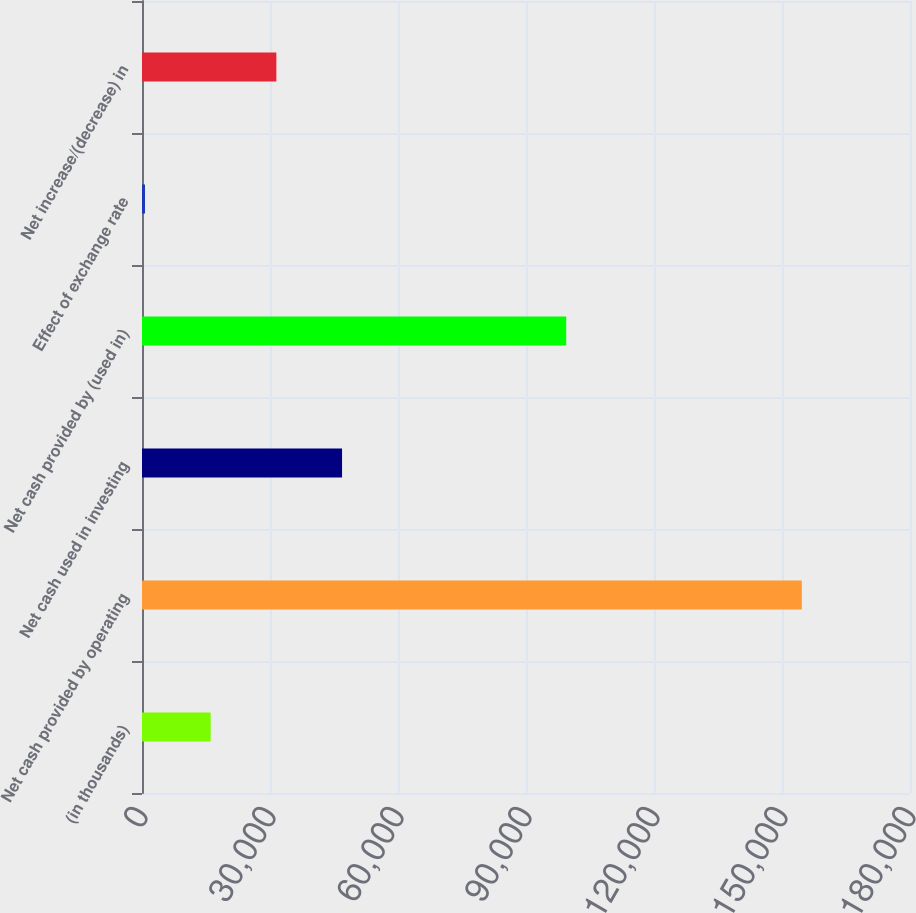Convert chart to OTSL. <chart><loc_0><loc_0><loc_500><loc_500><bar_chart><fcel>(in thousands)<fcel>Net cash provided by operating<fcel>Net cash used in investing<fcel>Net cash provided by (used in)<fcel>Effect of exchange rate<fcel>Net increase/(decrease) in<nl><fcel>16098.3<fcel>154647<fcel>46886.9<fcel>99427<fcel>704<fcel>31492.6<nl></chart> 